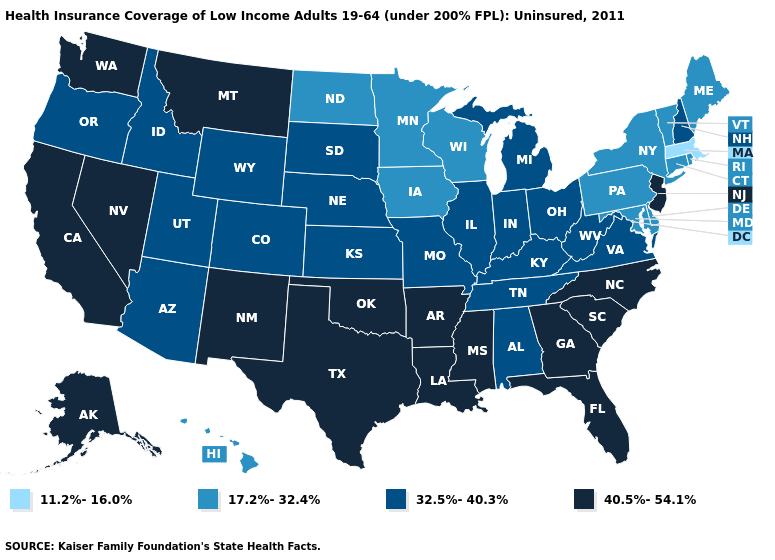What is the highest value in states that border North Carolina?
Be succinct. 40.5%-54.1%. Name the states that have a value in the range 11.2%-16.0%?
Quick response, please. Massachusetts. What is the value of New Jersey?
Write a very short answer. 40.5%-54.1%. Does Massachusetts have the lowest value in the USA?
Answer briefly. Yes. What is the value of Indiana?
Quick response, please. 32.5%-40.3%. What is the value of Georgia?
Answer briefly. 40.5%-54.1%. Among the states that border Oregon , which have the lowest value?
Short answer required. Idaho. What is the highest value in the USA?
Keep it brief. 40.5%-54.1%. What is the value of Virginia?
Give a very brief answer. 32.5%-40.3%. Does the map have missing data?
Answer briefly. No. Does Georgia have the highest value in the USA?
Short answer required. Yes. Does Pennsylvania have the lowest value in the USA?
Concise answer only. No. Name the states that have a value in the range 32.5%-40.3%?
Give a very brief answer. Alabama, Arizona, Colorado, Idaho, Illinois, Indiana, Kansas, Kentucky, Michigan, Missouri, Nebraska, New Hampshire, Ohio, Oregon, South Dakota, Tennessee, Utah, Virginia, West Virginia, Wyoming. Name the states that have a value in the range 32.5%-40.3%?
Write a very short answer. Alabama, Arizona, Colorado, Idaho, Illinois, Indiana, Kansas, Kentucky, Michigan, Missouri, Nebraska, New Hampshire, Ohio, Oregon, South Dakota, Tennessee, Utah, Virginia, West Virginia, Wyoming. Which states have the lowest value in the USA?
Concise answer only. Massachusetts. 